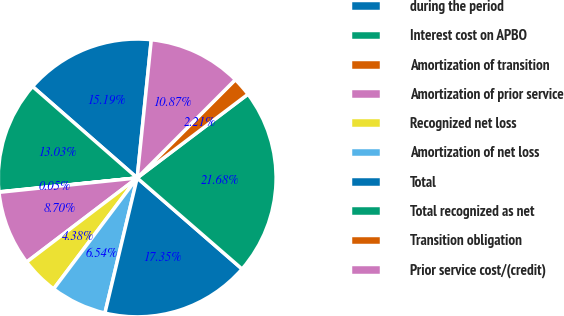Convert chart to OTSL. <chart><loc_0><loc_0><loc_500><loc_500><pie_chart><fcel>during the period<fcel>Interest cost on APBO<fcel>Amortization of transition<fcel>Amortization of prior service<fcel>Recognized net loss<fcel>Amortization of net loss<fcel>Total<fcel>Total recognized as net<fcel>Transition obligation<fcel>Prior service cost/(credit)<nl><fcel>15.19%<fcel>13.03%<fcel>0.05%<fcel>8.7%<fcel>4.38%<fcel>6.54%<fcel>17.35%<fcel>21.68%<fcel>2.21%<fcel>10.87%<nl></chart> 